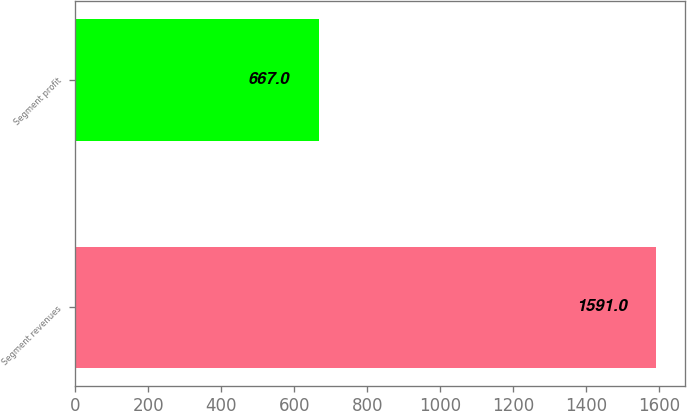Convert chart. <chart><loc_0><loc_0><loc_500><loc_500><bar_chart><fcel>Segment revenues<fcel>Segment profit<nl><fcel>1591<fcel>667<nl></chart> 